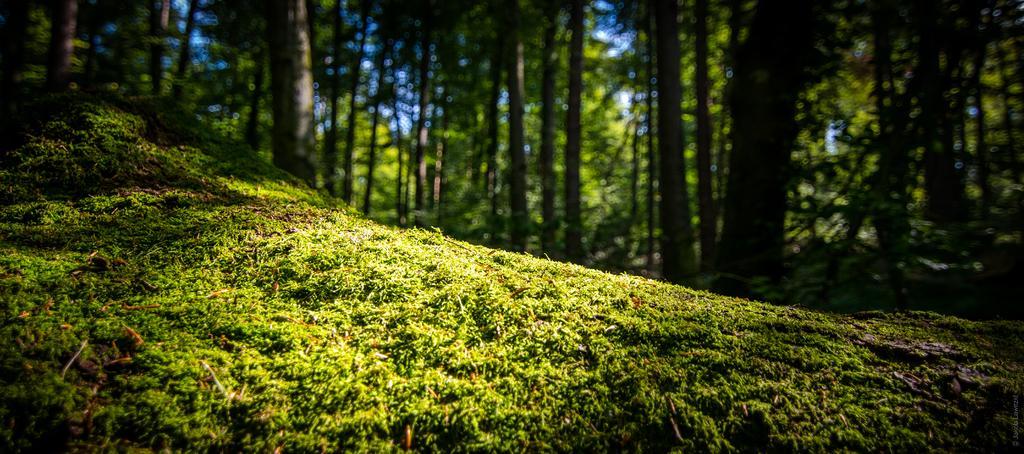Describe this image in one or two sentences. In this image in the center there is grass on the ground and in the background there are trees. 